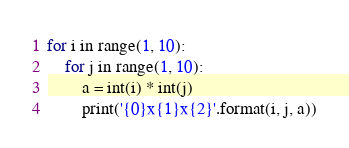Convert code to text. <code><loc_0><loc_0><loc_500><loc_500><_Python_>for i in range(1, 10):
    for j in range(1, 10):
        a = int(i) * int(j)
        print('{0}x{1}x{2}'.format(i, j, a))</code> 